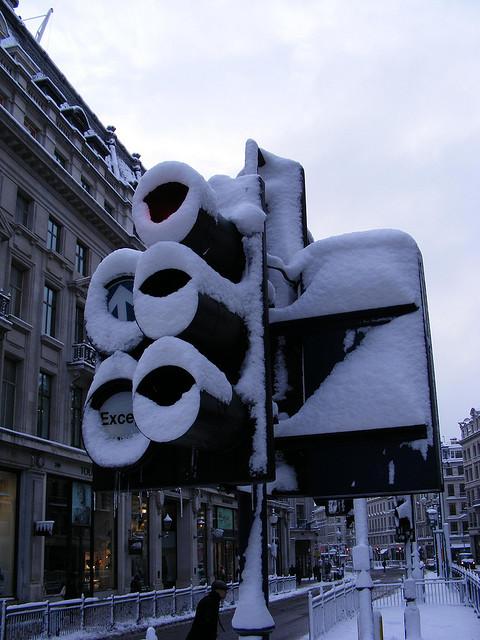What numbers are seen?
Short answer required. 0. Are there any lights on?
Concise answer only. No. Is it cold here?
Concise answer only. Yes. 